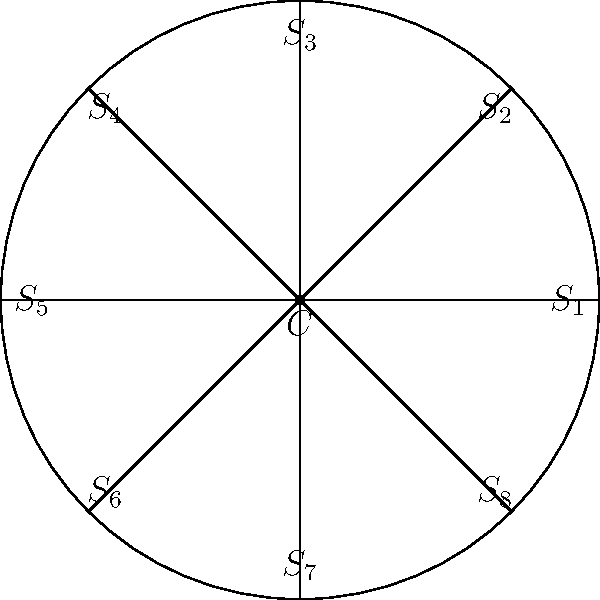In a circular stadium designed for the FIFA World Cup, there are 8 identical seating sections arranged symmetrically around a central point $C$, as shown in the diagram. Each section is labeled $S_1$ through $S_8$. The stadium management wants to implement a rotation system for fairness in ticket allocation. If the stadium is rotated clockwise by 90°, which section will occupy the position initially held by $S_1$? To solve this problem, we need to understand the concept of rotational symmetry and how it applies to the stadium seating arrangement:

1. The stadium has 8 identical sections arranged in a circle, which means it has 8-fold rotational symmetry.

2. Each section occupies 360° / 8 = 45° of the circle.

3. A clockwise rotation of 90° is equivalent to moving 2 sections clockwise, because:
   90° / 45° per section = 2 sections

4. Starting from $S_1$, we need to count 2 sections clockwise to find which section will take its place after the rotation.

5. Counting clockwise: $S_1 \rightarrow S_8 \rightarrow S_7$

Therefore, after a 90° clockwise rotation, section $S_7$ will occupy the position initially held by $S_1$.
Answer: $S_7$ 